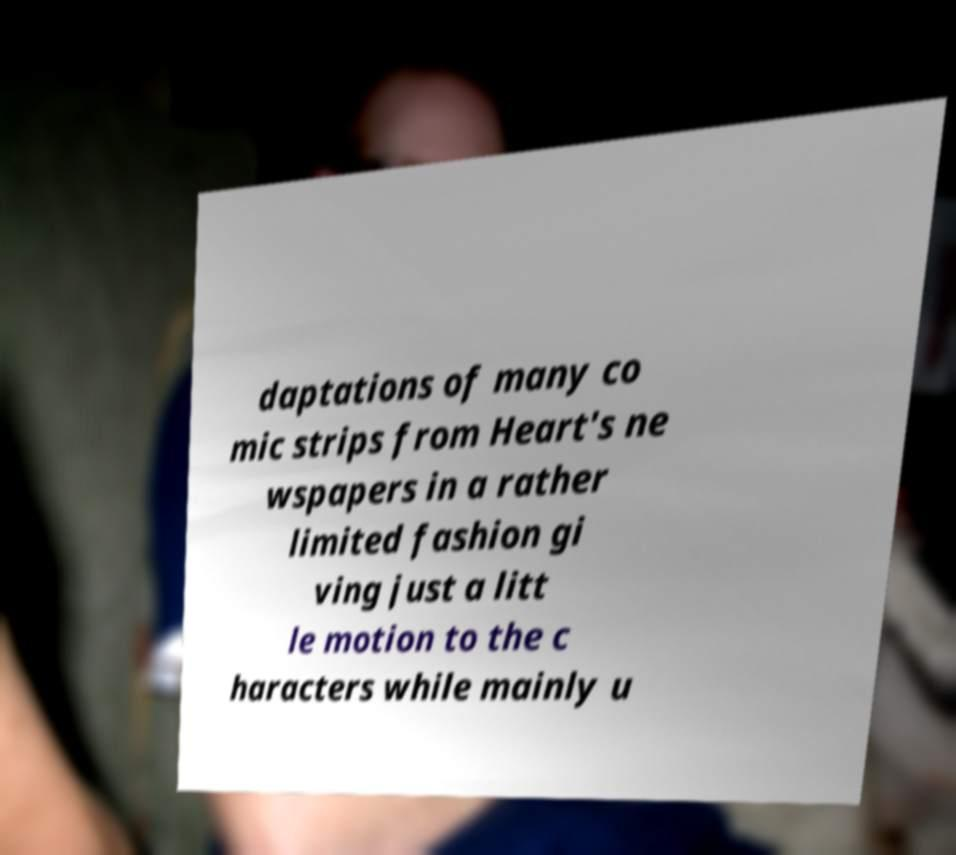Can you accurately transcribe the text from the provided image for me? daptations of many co mic strips from Heart's ne wspapers in a rather limited fashion gi ving just a litt le motion to the c haracters while mainly u 